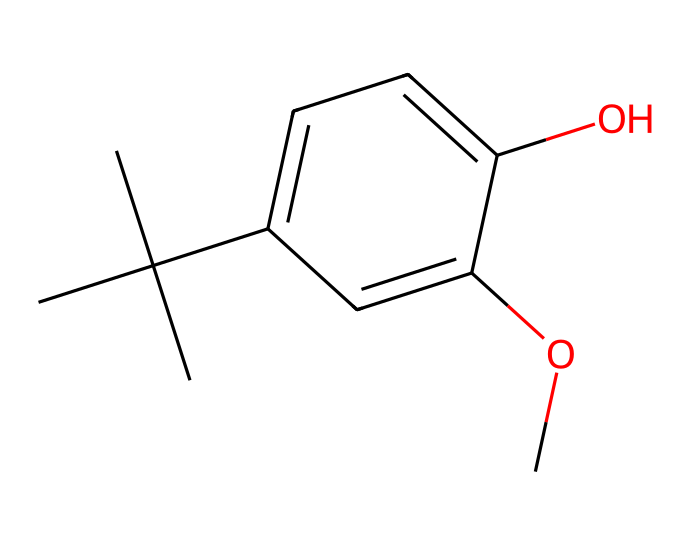What is the molecular formula of butylated hydroxyanisole (BHA)? By interpreting the SMILES representation, we can identify the number of carbon (C), hydrogen (H), and oxygen (O) atoms present. The structure indicates that there are 11 carbons, 16 hydrogens, and 2 oxygens. Combining these counts gives the molecular formula C11H16O2.
Answer: C11H16O2 How many hydroxyl (-OH) groups are present in this molecule? Looking at the structure, a hydroxyl group is visibly attached to the aromatic ring. There is only one -OH group in the chemical structure of BHA.
Answer: 1 What type of reaction is butylated hydroxyanisole (BHA) primarily used for in food preservation? BHA is primarily used as an antioxidant in food preservation to prevent oxidative rancidity, thus preserving the flavor and shelf life of food products.
Answer: antioxidant What does the "butylated" in butylated hydroxyanisole refer to? The term "butylated" indicates the presence of a butyl group, which refers to the branched alkyl group found in the structure (specifically the tert-butyl group).
Answer: tert-butyl group Which part of BHA contributes to its antioxidant properties? The presence of the hydroxyl group (the -OH) is crucial for its ability to donate hydrogen and neutralize free radicals, thus conferring antioxidant properties.
Answer: -OH group How many total rings are present in butylated hydroxyanisole? In the structure of BHA, there is one aromatic ring present in the molecule, which is typical for many antioxidant compounds.
Answer: 1 